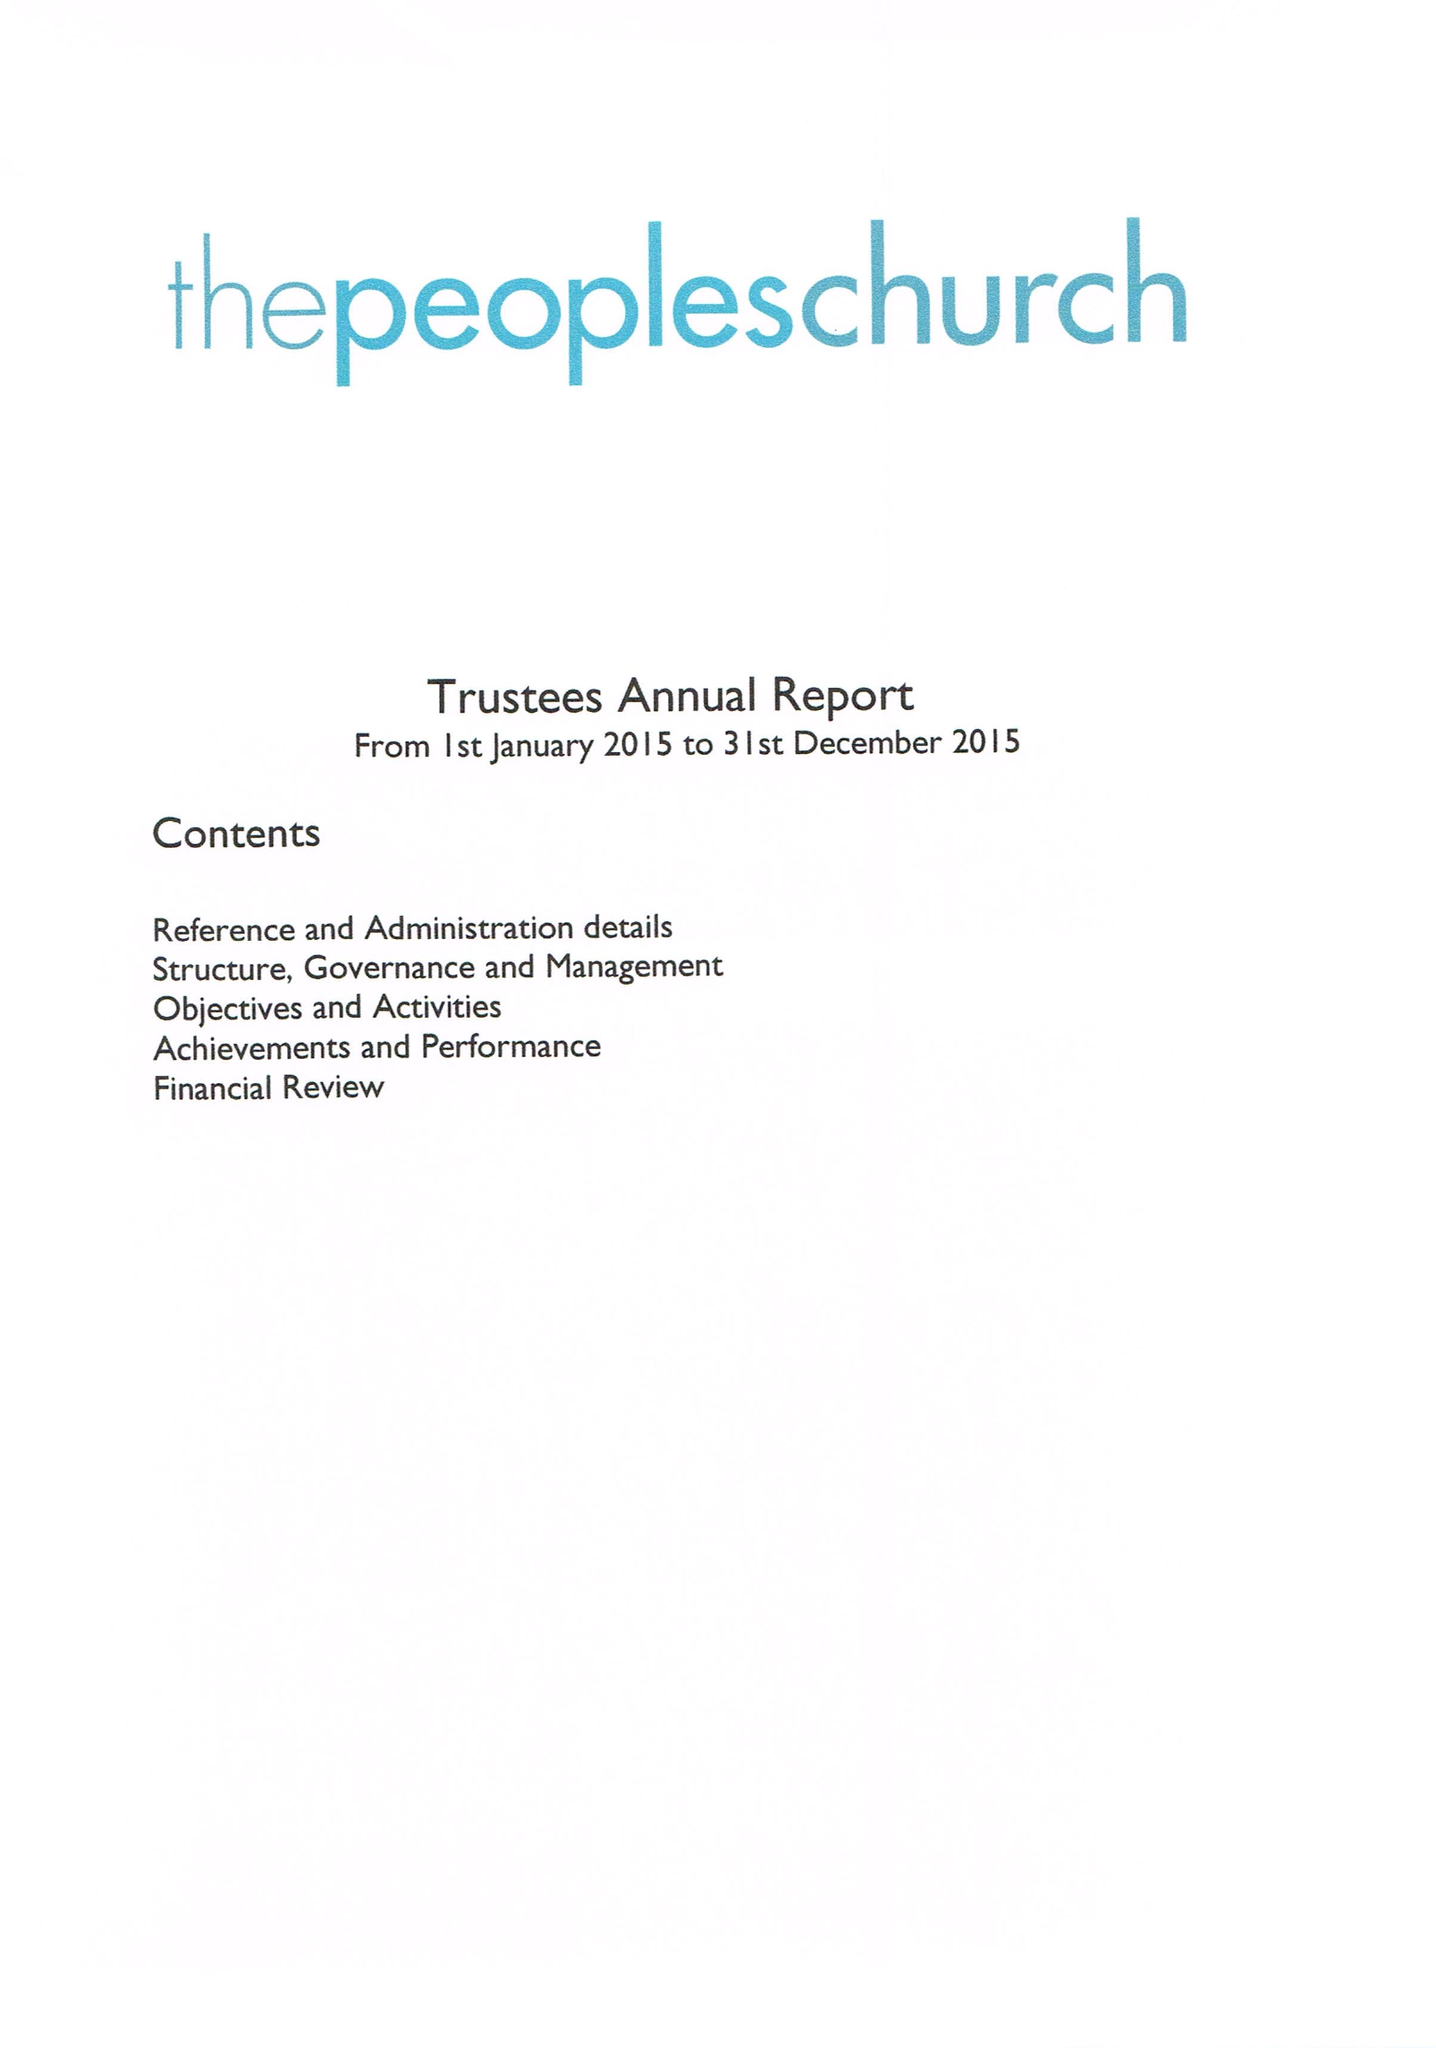What is the value for the address__post_town?
Answer the question using a single word or phrase. BANBURY 